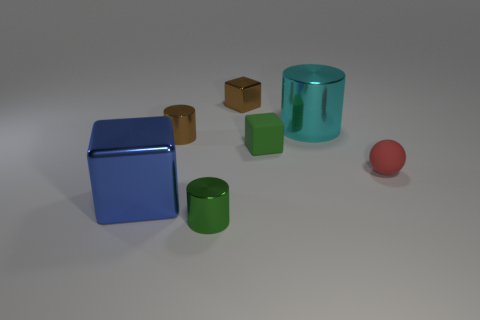Add 1 tiny red metal cylinders. How many objects exist? 8 Subtract all cubes. How many objects are left? 4 Subtract 1 cyan cylinders. How many objects are left? 6 Subtract all purple matte things. Subtract all tiny shiny cylinders. How many objects are left? 5 Add 7 brown shiny things. How many brown shiny things are left? 9 Add 2 small yellow shiny cubes. How many small yellow shiny cubes exist? 2 